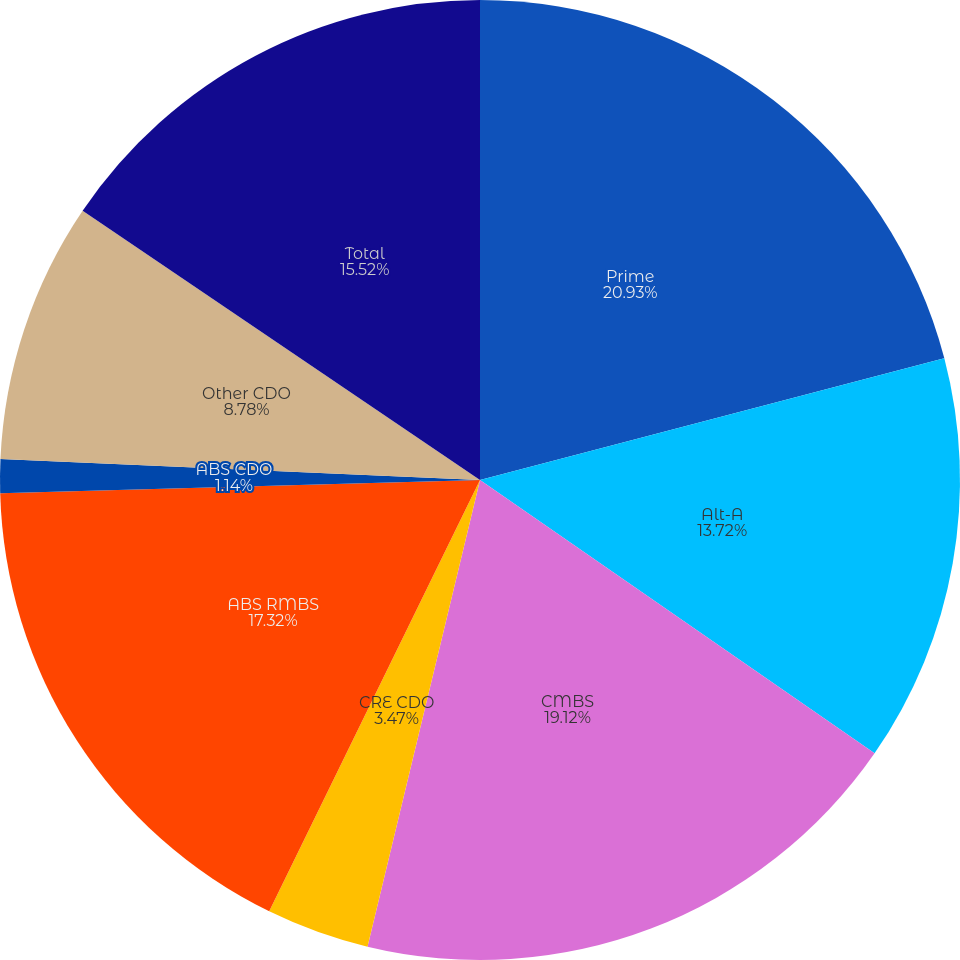Convert chart. <chart><loc_0><loc_0><loc_500><loc_500><pie_chart><fcel>Prime<fcel>Alt-A<fcel>CMBS<fcel>CRE CDO<fcel>ABS RMBS<fcel>ABS CDO<fcel>Other CDO<fcel>Total<nl><fcel>20.92%<fcel>13.72%<fcel>19.12%<fcel>3.47%<fcel>17.32%<fcel>1.14%<fcel>8.78%<fcel>15.52%<nl></chart> 